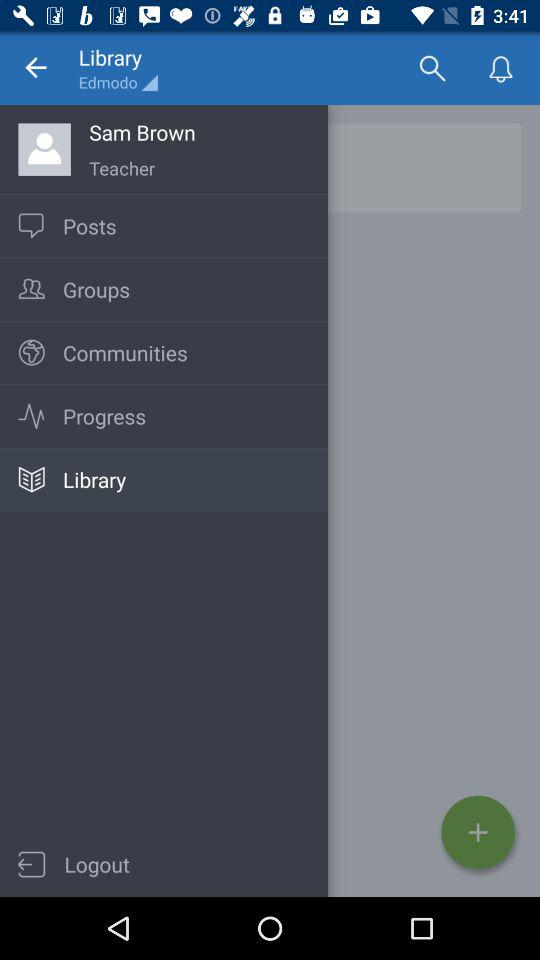Which item has been selected in the menu? The item "Library" has been selected. 